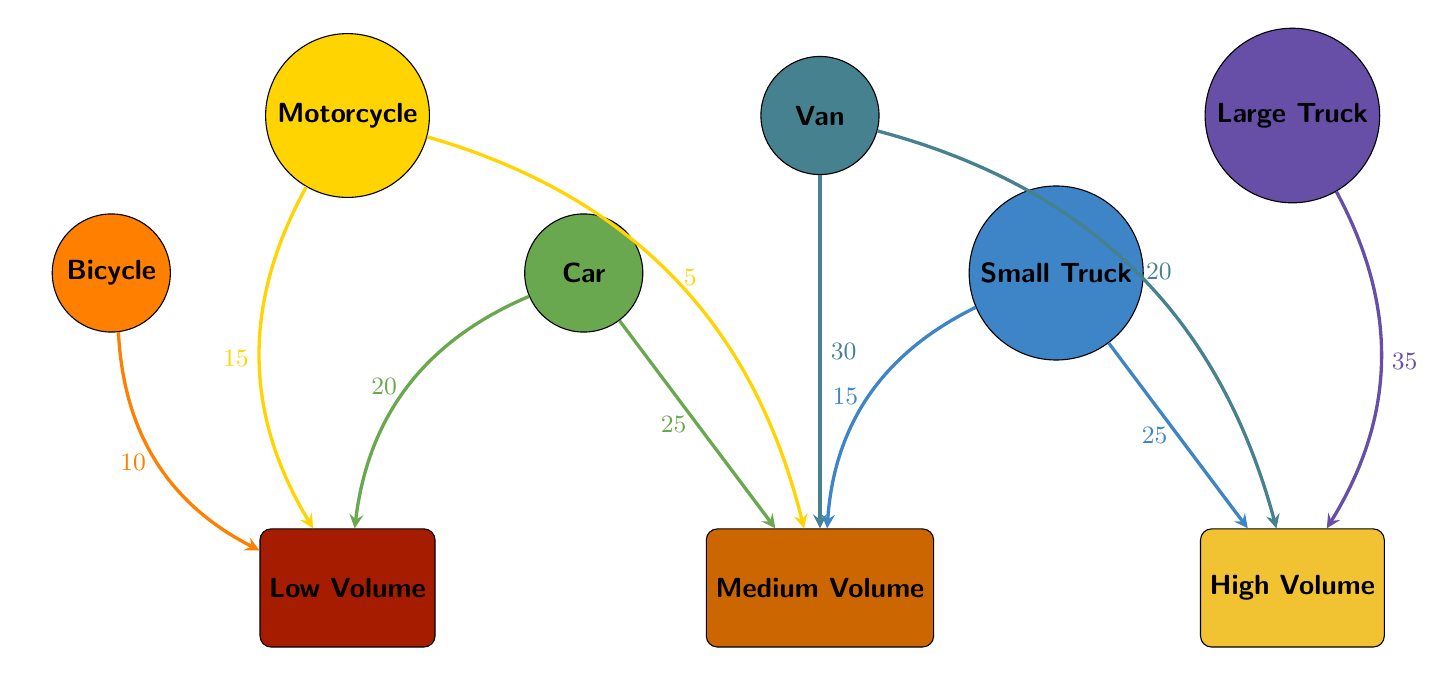What is the total number of vehicles represented in the diagram? The diagram contains six vehicle types: Bicycle, Motorcycle, Car, Van, Small Truck, and Large Truck. Hence, the total is 6.
Answer: 6 Which vehicle is used for medium volume deliveries the most? The Van is represented with the highest link value for medium volume (30). Hence, it is the vehicle used the most for medium volume deliveries.
Answer: Van What is the flow value from Small Truck to High Volume? The diagram shows a flow from Small Truck to High Volume with a value of 25.
Answer: 25 Which vehicle has the highest delivery volume capacity? The Large Truck, with a flow value of 35 to High Volume, indicates it has the highest delivery volume capacity among all vehicle types.
Answer: Large Truck How many vehicles are used for low volume deliveries? The Bicycle, Motorcycle, and Car are the only vehicles with links to Low Volume. That makes it three vehicles.
Answer: 3 What is the sum of flow values for vehicles delivering to Medium Volume? The flow values to Medium Volume are 5 from Motorcycle, 25 from Car, 30 from Van, and 15 from Small Truck. Adding these values gives 5 + 25 + 30 + 15 = 75.
Answer: 75 Which vehicle type has no connection to High Volume? The Bicycle and Motorcycle do not have links to High Volume at all. Therefore, they are the vehicle types without any connection.
Answer: Bicycle, Motorcycle What vehicle type contributes the least to Low Volume deliveries? The flow value from Motorcycle to Low Volume is 15, which is lower than that from Bicycle (10) and Car (20). However, since we're looking for the least, and the Bicycle contributes 10, it is the least contributor.
Answer: Bicycle 